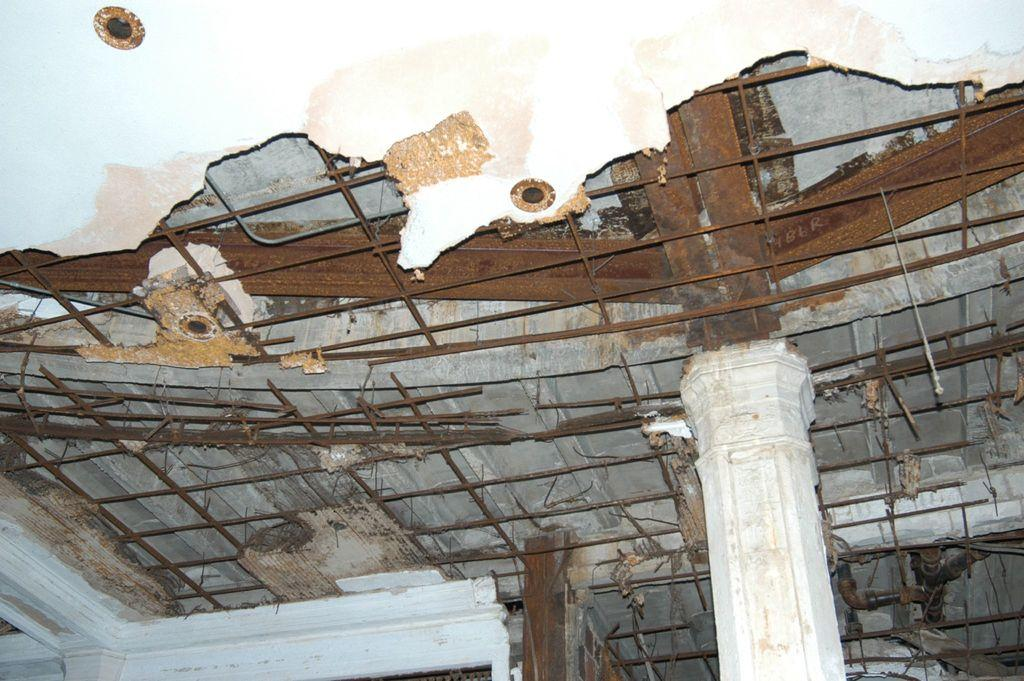What is located above the scene in the image? There is a ceiling in the image. What type of structural elements can be seen in the image? There are rods and a pillar in the image. How many experts are sitting in the cave in the image? There is no cave or experts present in the image. What type of chair is placed near the pillar in the image? There is no chair present in the image. 